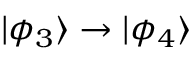<formula> <loc_0><loc_0><loc_500><loc_500>| \phi _ { 3 } \rangle \rightarrow | \phi _ { 4 } \rangle</formula> 